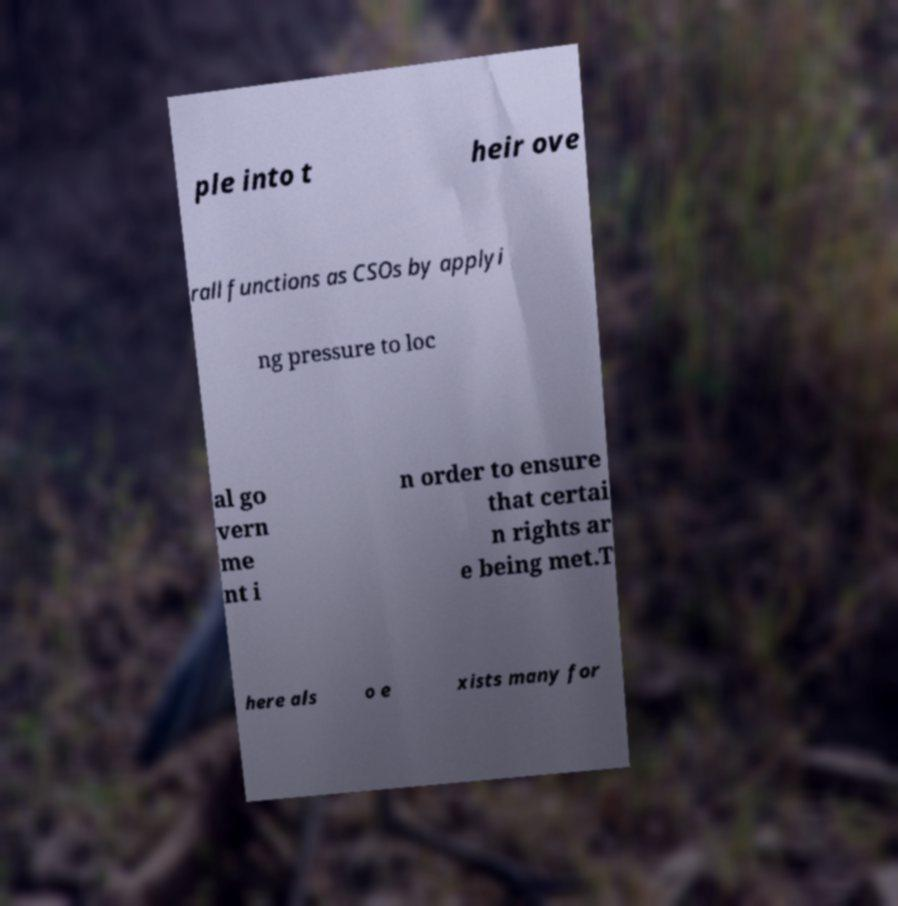Please read and relay the text visible in this image. What does it say? ple into t heir ove rall functions as CSOs by applyi ng pressure to loc al go vern me nt i n order to ensure that certai n rights ar e being met.T here als o e xists many for 